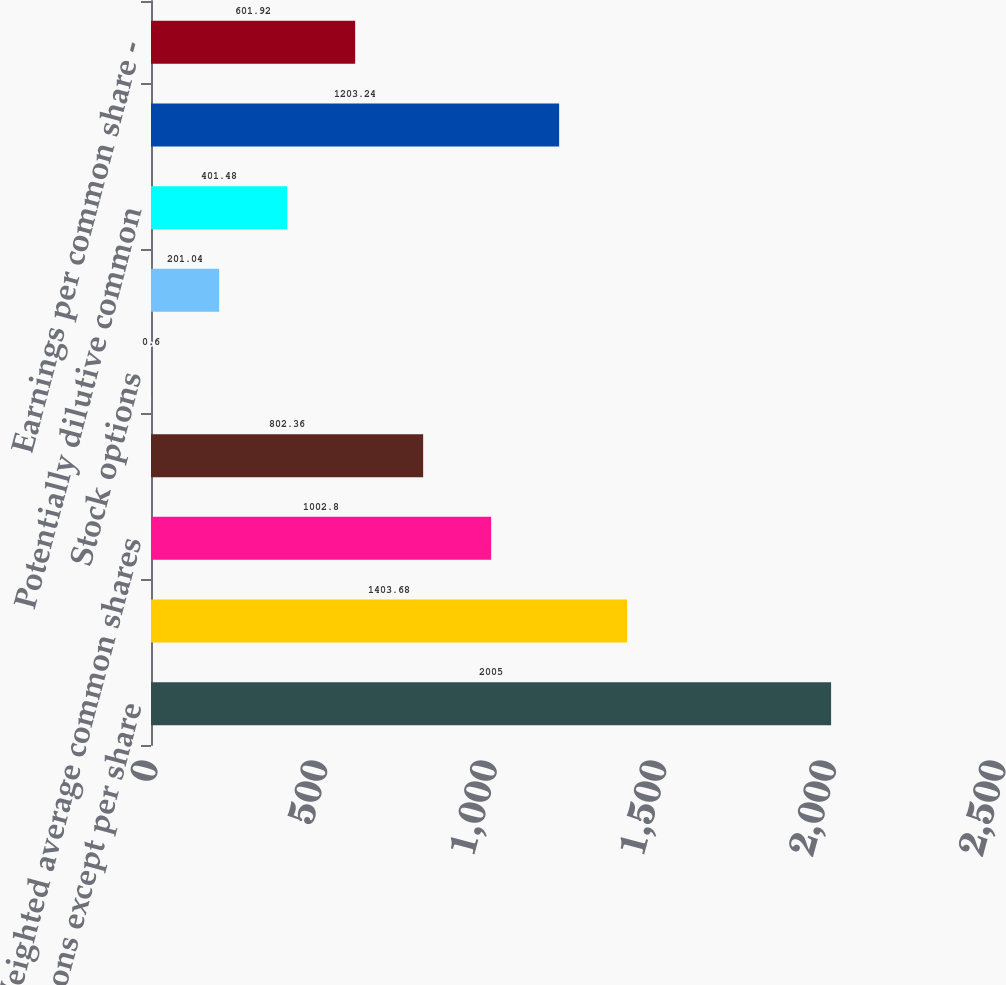<chart> <loc_0><loc_0><loc_500><loc_500><bar_chart><fcel>(Millions except per share<fcel>Net income<fcel>Weighted average common shares<fcel>Earnings per common share<fcel>Stock options<fcel>Other stock compensation plans<fcel>Potentially dilutive common<fcel>Adjusted weighted average<fcel>Earnings per common share -<nl><fcel>2005<fcel>1403.68<fcel>1002.8<fcel>802.36<fcel>0.6<fcel>201.04<fcel>401.48<fcel>1203.24<fcel>601.92<nl></chart> 